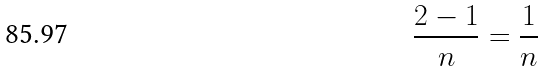Convert formula to latex. <formula><loc_0><loc_0><loc_500><loc_500>\frac { 2 - 1 } { n } = \frac { 1 } { n }</formula> 